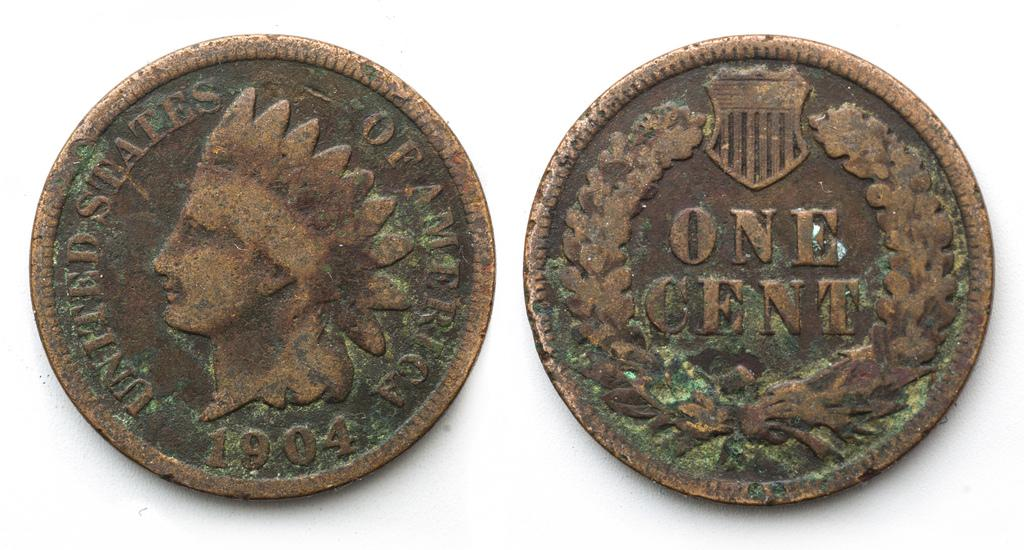<image>
Give a short and clear explanation of the subsequent image. two very old coins shown here, the second one is a one cent coin 